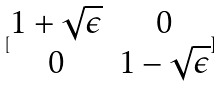Convert formula to latex. <formula><loc_0><loc_0><loc_500><loc_500>[ \begin{matrix} 1 + \sqrt { \epsilon } & 0 \\ 0 & 1 - \sqrt { \epsilon } \end{matrix} ]</formula> 